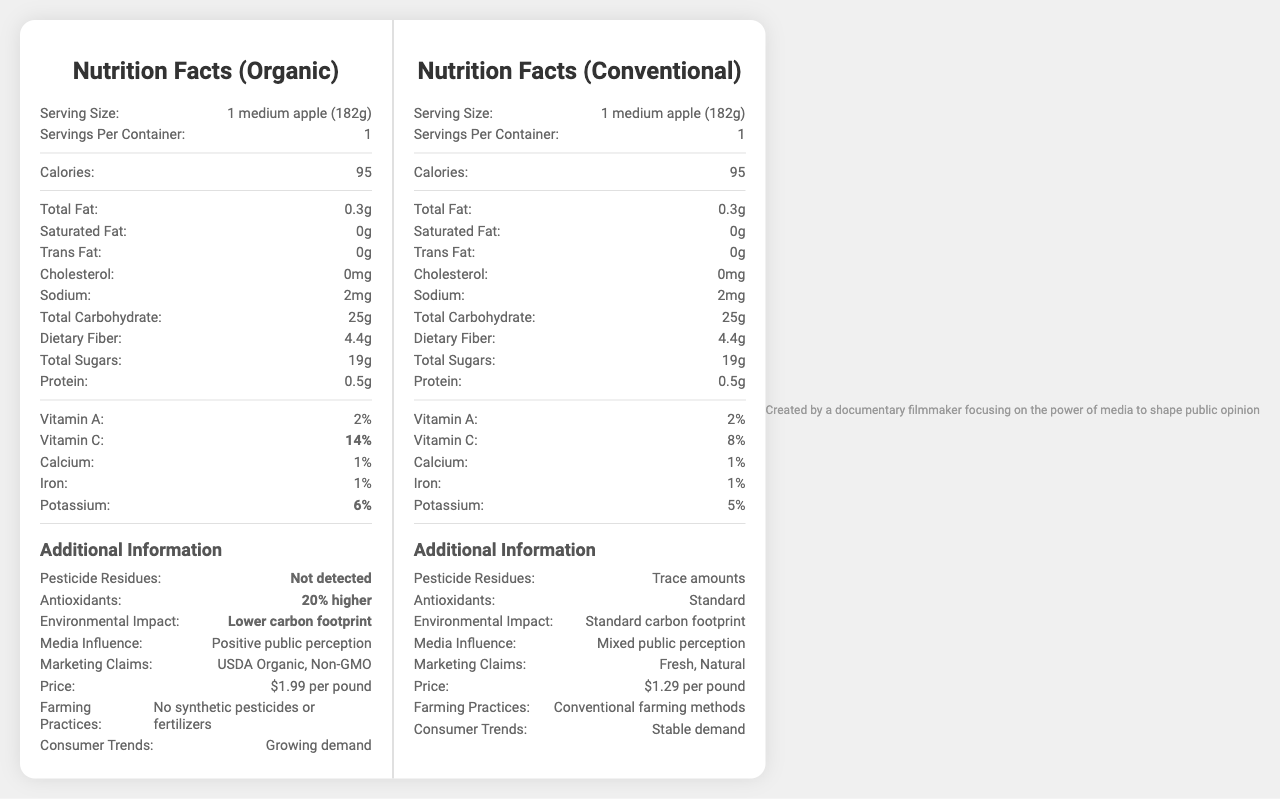what is the serving size for the apples? The serving size is listed at the top of both the organic and conventional nutrition labels.
Answer: 1 medium apple (182g) how many calories are in one serving of both organic and conventional apples? The calorie content for both organic and conventional apples is 95.
Answer: 95 what is the difference in vitamin C content between organic and conventional apples? Organic apples have 14% vitamin C, whereas conventional apples have 8%, resulting in a difference of 6%.
Answer: 6% Do organic or conventional apples have more potassium? Organic apples have 6% potassium, whereas conventional apples have 5%.
Answer: Organic What is the price per pound for organic apples? The price comparison section lists the price for organic apples as $1.99 per pound.
Answer: $1.99 per pound Which type of apple has detected pesticide residues? A. Organic B. Conventional C. Both The label indicates that pesticide residues are "Not detected" in organic apples but show "Trace amounts" in conventional apples.
Answer: B Based on the label, which farming practices are used for organic apples? A. No synthetic pesticides or fertilizers B. Use of synthetic pesticides and fertilizers C. Hydroponic farming The label indicates that organic apples are grown with no synthetic pesticides or fertilizers.
Answer: A How do organic apples rank in terms of media influence? A. Negative public perception B. Mixed public perception C. Positive public perception The label describes organic apples as having a "Positive public perception."
Answer: C Do both organic and conventional apples have cholesterol? Both types of apples list 0mg cholesterol.
Answer: No Summarize the main differences between organic and conventional apples highlighted in the document. The document provides a comparative breakdown of nutritional content, pesticide residues, antioxidant levels, environmental impact, media influence, marketing claims, price, farming practices, and consumer trends between organic and conventional apples, highlighting the benefits and downsides of each.
Answer: Organic apples have no detected pesticide residues, 20% higher antioxidants, a lower carbon footprint, and a price of $1.99 per pound. Conventional apples have trace pesticide residues, standard antioxidant levels, a standard carbon footprint, and a price of $1.29 per pound. Organic apples also benefit from a positive public perception, while conventional apples have a mixed public perception. Which type of apple consumption is linked with a lower environmental impact? The environmental impact section indicates that organic apples have a "Lower carbon footprint."
Answer: Organic What are the marketing claims associated with conventional apples? The label lists the marketing claims for conventional apples as "Fresh, Natural."
Answer: Fresh, Natural How much total carbohydrate is in a serving of organic apples? The total carbohydrate content for organic apples is listed as 25g. This is the same for conventional apples.
Answer: 25g Is the amount of protein in conventional apples different from organic apples? Both organic and conventional apples have 0.5g of protein per serving.
Answer: No Which type of apple shows a growing consumer demand according to the label? A. Organic B. Conventional C. Both The consumer trends section indicates a "Growing demand" for organic apples, while conventional apples have a "Stable demand."
Answer: A Are organic apples non-GMO according to the marketing claims? The marketing claims for organic apples include "USDA Organic, Non-GMO."
Answer: Yes provide a detailed comparison of the nutrient content (excluding additional information) between organic and conventional apples. The nutrient content between organic and conventional apples is largely identical, with both types offering 95 calories, 0.3g total fat, 0g saturated fat, 0g trans fat, 0mg cholesterol, 2mg sodium, 25g total carbohydrate, 4.4g dietary fiber, 19g total sugars, 0.5g protein, 2% vitamin A, 1% calcium, and 1% iron. However, organic apples have 14% vitamin C compared to 8% in conventional apples, and 6% potassium compared to 5% in conventional apples.
Answer: Both organic and conventional apples have similar nutrient content in terms of calories, total fat, saturated fat, trans fat, cholesterol, sodium, total carbohydrate, dietary fiber, total sugars, protein, vitamin A, calcium, and iron. The main differences are in Vitamin C and potassium, where organic apples have slightly higher values. What is the primary benefit of organic apples in terms of antioxidants mentioned in the document? The document indicates that antioxidants in organic apples are 20% higher than in conventional apples.
Answer: 20% higher Can you determine the exact date when the label was last updated? The document does not provide any information regarding the exact date when the label was last updated.
Answer: Cannot be determined 